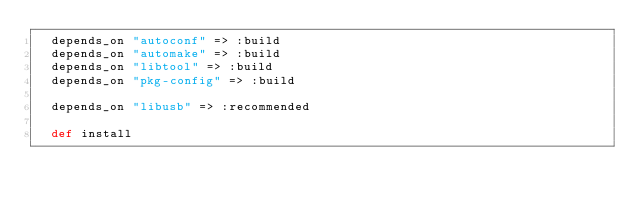Convert code to text. <code><loc_0><loc_0><loc_500><loc_500><_Ruby_>  depends_on "autoconf" => :build
  depends_on "automake" => :build
  depends_on "libtool" => :build
  depends_on "pkg-config" => :build

  depends_on "libusb" => :recommended

  def install</code> 